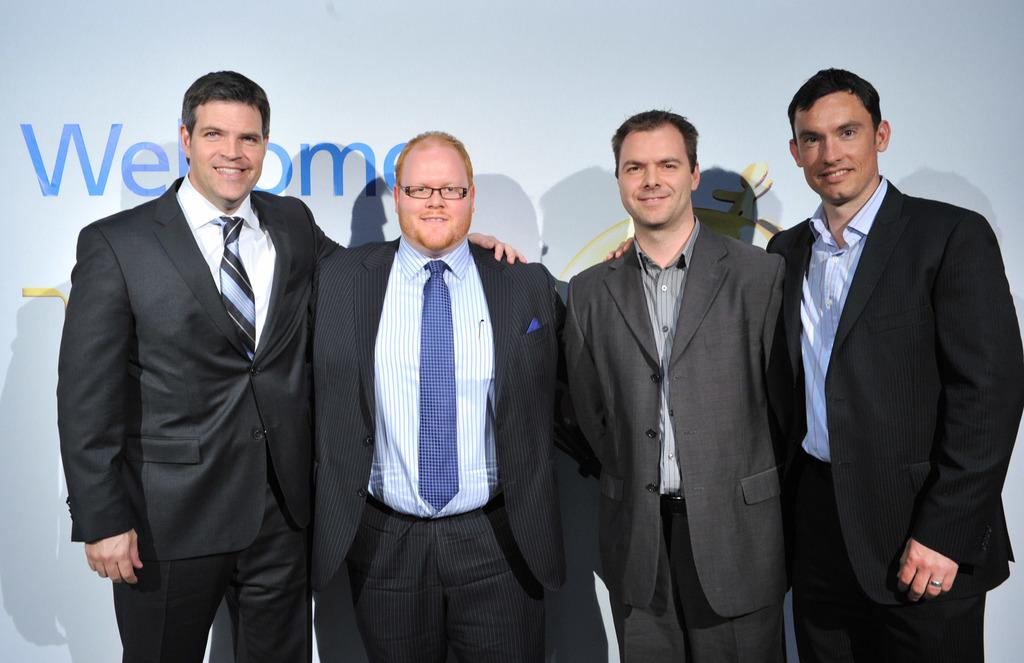How many people are in the image? There are four persons in the image. What are the people wearing in the image? Each person is wearing a suit and a tie. What is the facial expression of the people in the image? The persons are smiling. Can you see a snail crawling on the person's shoulder in the image? No, there is no snail present in the image. What type of mountain can be seen in the background of the image? There is no mountain visible in the image; it only features the four persons wearing suits and ties. 